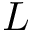<formula> <loc_0><loc_0><loc_500><loc_500>L</formula> 